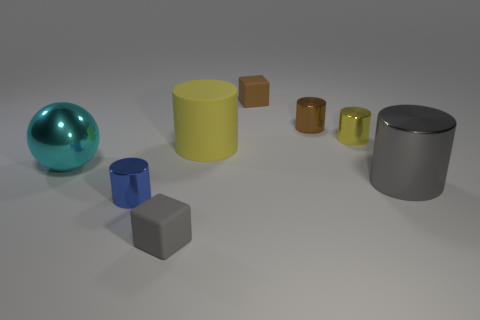Are there fewer big gray objects that are to the left of the tiny brown block than yellow cylinders that are behind the yellow shiny thing?
Your response must be concise. No. What is the shape of the gray object that is made of the same material as the brown cylinder?
Make the answer very short. Cylinder. What is the size of the rubber cylinder behind the metallic cylinder that is to the left of the small rubber block that is in front of the large gray cylinder?
Your answer should be very brief. Large. Are there more small blue objects than tiny blocks?
Your answer should be compact. No. Do the tiny rubber cube that is in front of the yellow rubber object and the large metal thing to the right of the gray block have the same color?
Give a very brief answer. Yes. Is the yellow cylinder to the right of the brown rubber block made of the same material as the cylinder that is on the left side of the gray matte cube?
Offer a terse response. Yes. What number of cylinders are the same size as the cyan sphere?
Offer a very short reply. 2. Is the number of big rubber objects less than the number of tiny gray matte cylinders?
Provide a succinct answer. No. What shape is the big metal object that is on the left side of the large thing in front of the cyan shiny sphere?
Ensure brevity in your answer.  Sphere. There is a gray matte object that is the same size as the brown block; what shape is it?
Your response must be concise. Cube. 